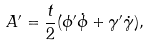<formula> <loc_0><loc_0><loc_500><loc_500>A ^ { \prime } = \frac { t } { 2 } ( \phi ^ { \prime } \dot { \phi } + \gamma ^ { \prime } \dot { \gamma } ) ,</formula> 